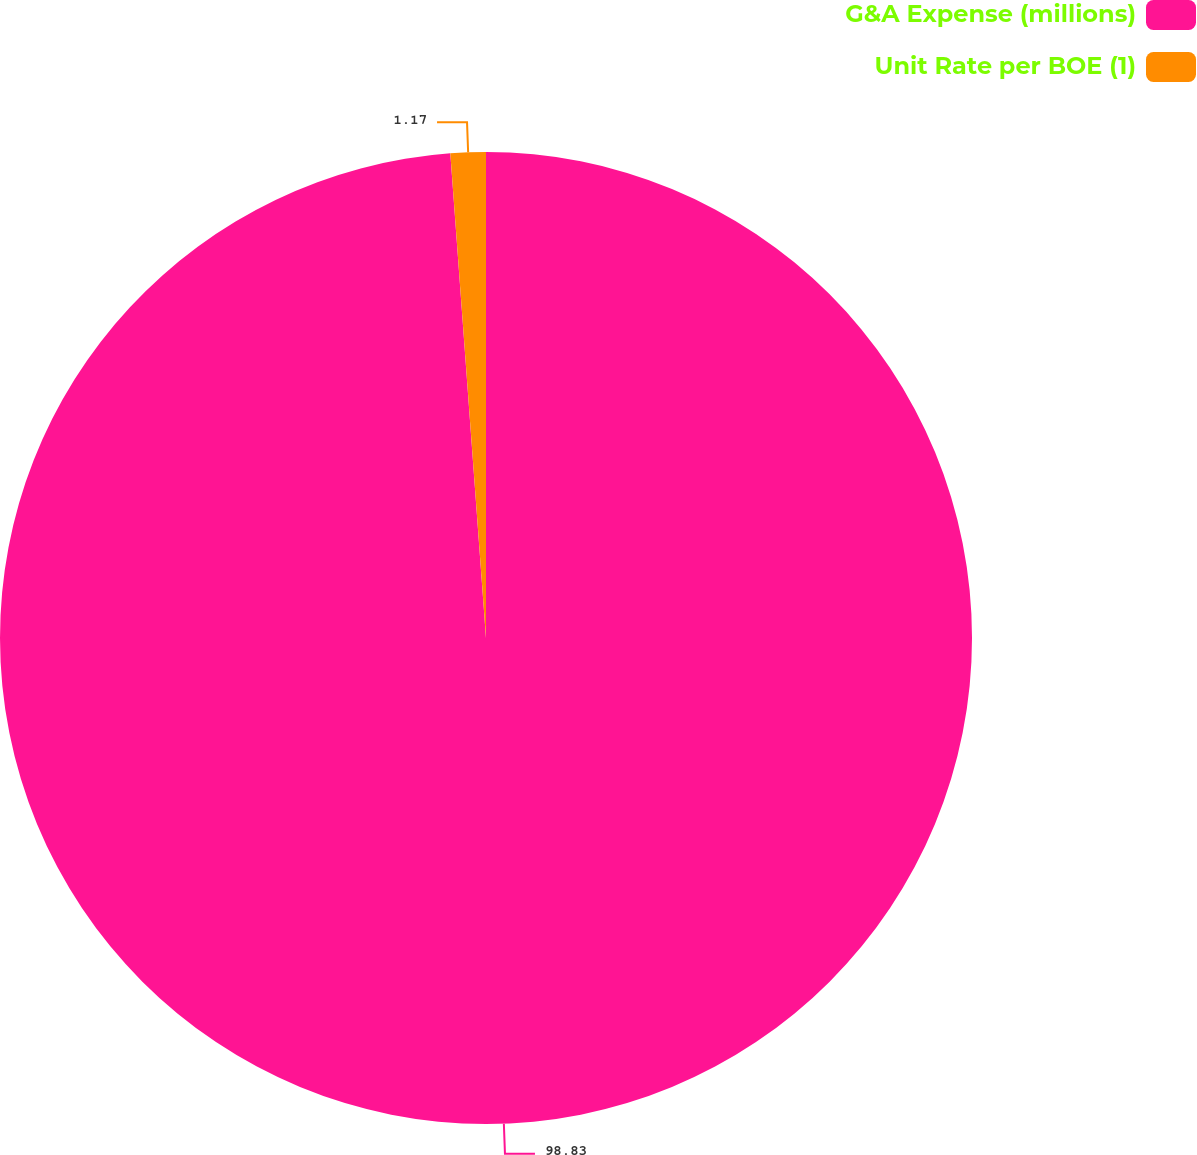<chart> <loc_0><loc_0><loc_500><loc_500><pie_chart><fcel>G&A Expense (millions)<fcel>Unit Rate per BOE (1)<nl><fcel>98.83%<fcel>1.17%<nl></chart> 